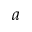Convert formula to latex. <formula><loc_0><loc_0><loc_500><loc_500>a</formula> 